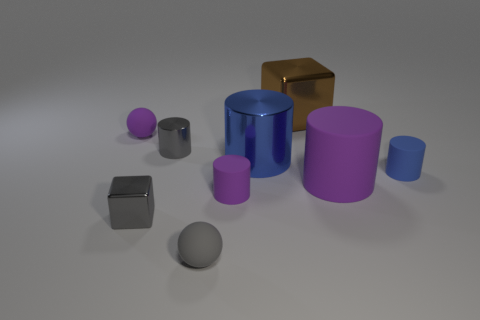Subtract all shiny cylinders. How many cylinders are left? 3 Subtract all gray balls. How many balls are left? 1 Subtract all brown balls. How many yellow cylinders are left? 0 Subtract all large cubes. Subtract all tiny gray shiny cubes. How many objects are left? 7 Add 1 small gray rubber things. How many small gray rubber things are left? 2 Add 2 gray rubber objects. How many gray rubber objects exist? 3 Add 1 small purple balls. How many objects exist? 10 Subtract 1 gray balls. How many objects are left? 8 Subtract all balls. How many objects are left? 7 Subtract 2 spheres. How many spheres are left? 0 